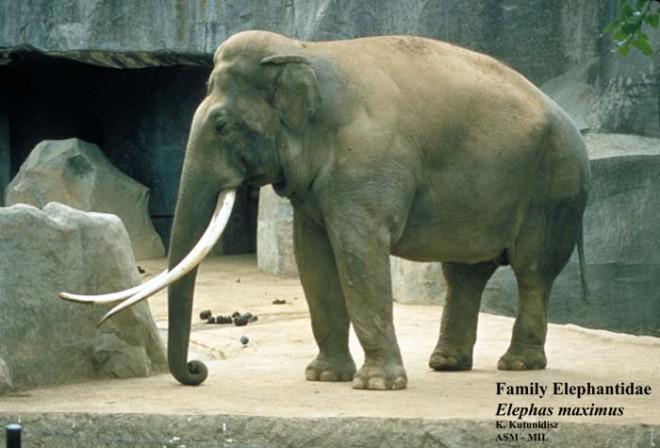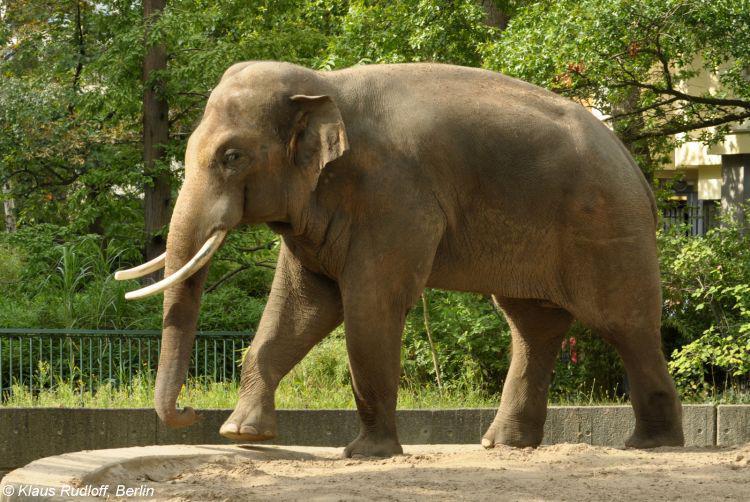The first image is the image on the left, the second image is the image on the right. Analyze the images presented: Is the assertion "The elephant in the image on the right has its feet on a man made structure." valid? Answer yes or no. Yes. The first image is the image on the left, the second image is the image on the right. Analyze the images presented: Is the assertion "Both elephants are facing towards the left." valid? Answer yes or no. Yes. 